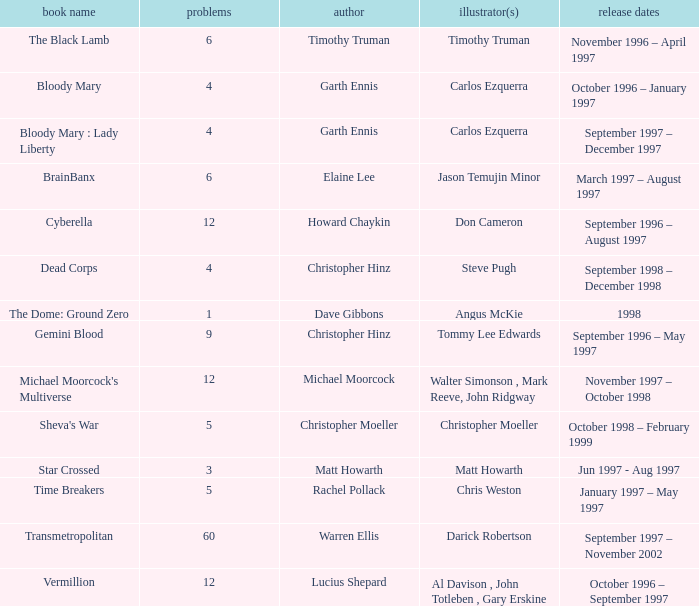What artist has a book called cyberella Don Cameron. 